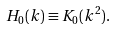<formula> <loc_0><loc_0><loc_500><loc_500>H _ { 0 } ( k ) \equiv K _ { 0 } ( k ^ { 2 } ) .</formula> 